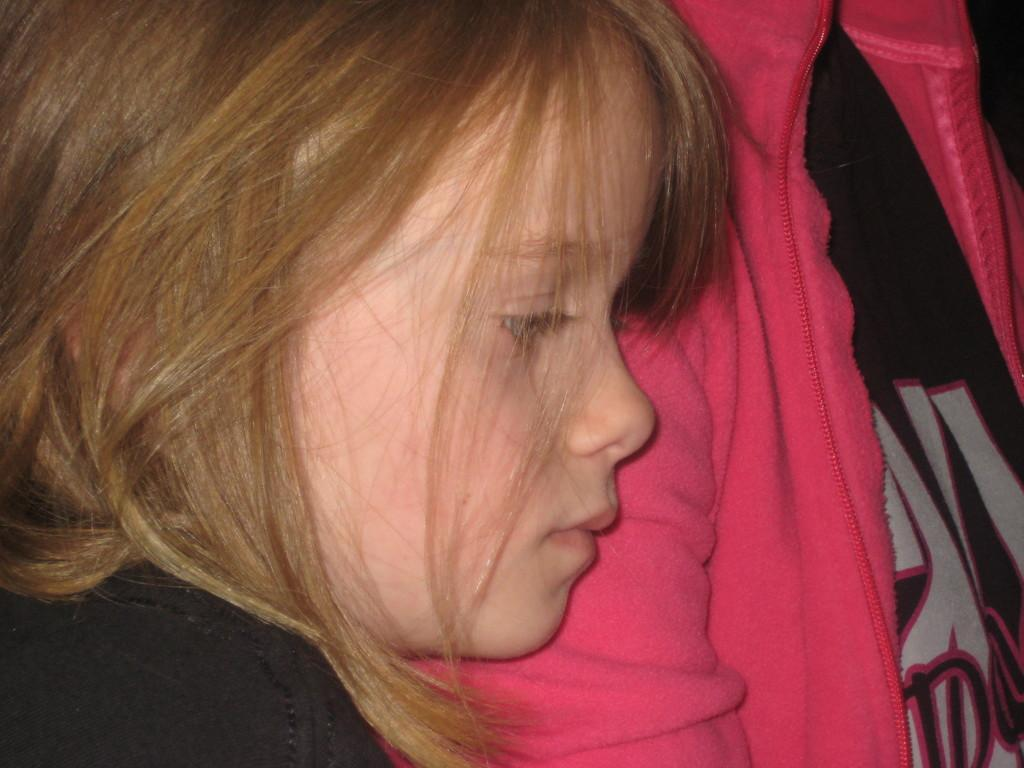What is the main subject of the image? There is a child in the image. Can you describe another person in the image? Yes, there is a person in the image. What type of hand can be seen waving good-bye in the image? There is no hand or good-bye gesture present in the image. 